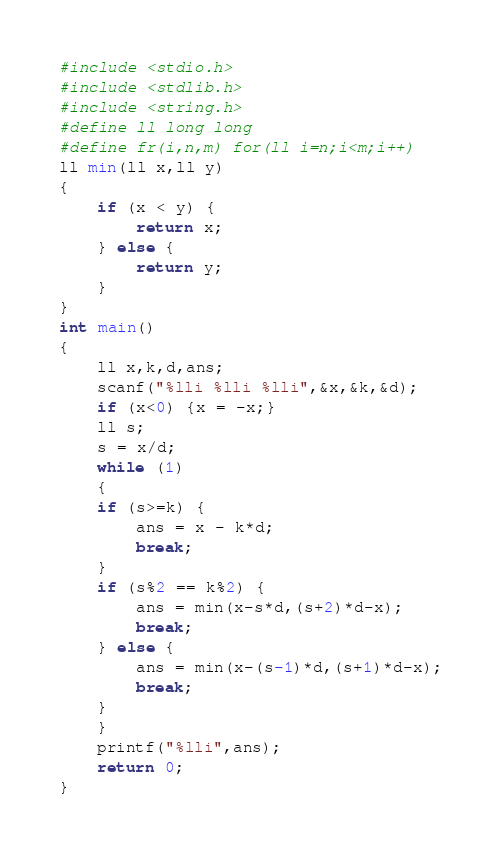Convert code to text. <code><loc_0><loc_0><loc_500><loc_500><_C_>#include <stdio.h>
#include <stdlib.h>
#include <string.h>
#define ll long long
#define fr(i,n,m) for(ll i=n;i<m;i++)
ll min(ll x,ll y)
{
    if (x < y) {
        return x;
    } else {
        return y;
    }
}
int main()
{
    ll x,k,d,ans;
    scanf("%lli %lli %lli",&x,&k,&d);
    if (x<0) {x = -x;}
    ll s;
    s = x/d;
    while (1)
    {
    if (s>=k) {
        ans = x - k*d;
        break;
    }
    if (s%2 == k%2) {
        ans = min(x-s*d,(s+2)*d-x);
        break;
    } else {
        ans = min(x-(s-1)*d,(s+1)*d-x);
        break;
    }
    }
    printf("%lli",ans);
    return 0;
}</code> 